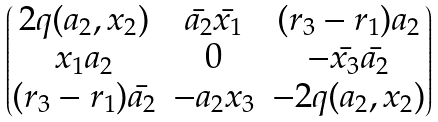<formula> <loc_0><loc_0><loc_500><loc_500>\begin{pmatrix} 2 q ( a _ { 2 } , x _ { 2 } ) & \bar { a _ { 2 } } \bar { x _ { 1 } } & ( r _ { 3 } - r _ { 1 } ) a _ { 2 } \\ x _ { 1 } a _ { 2 } & 0 & - \bar { x _ { 3 } } \bar { a _ { 2 } } \\ ( r _ { 3 } - r _ { 1 } ) \bar { a _ { 2 } } & - a _ { 2 } x _ { 3 } & - 2 q ( a _ { 2 } , x _ { 2 } ) \end{pmatrix}</formula> 